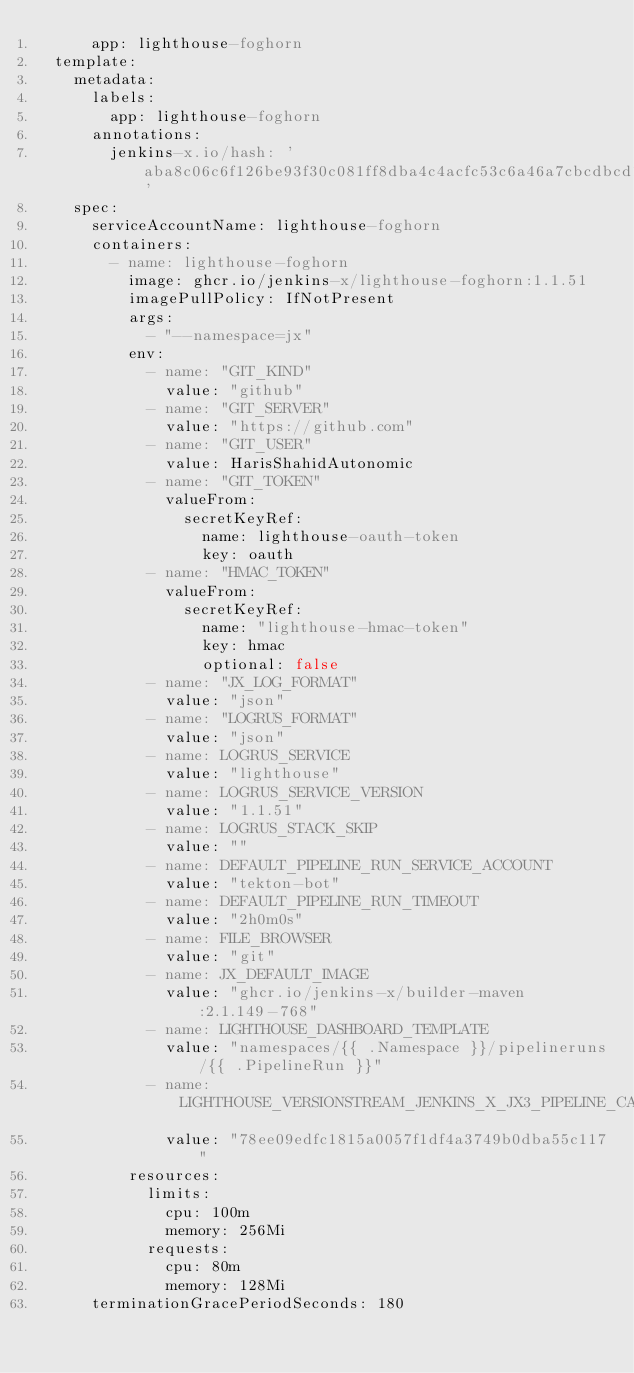Convert code to text. <code><loc_0><loc_0><loc_500><loc_500><_YAML_>      app: lighthouse-foghorn
  template:
    metadata:
      labels:
        app: lighthouse-foghorn
      annotations:
        jenkins-x.io/hash: 'aba8c06c6f126be93f30c081ff8dba4c4acfc53c6a46a7cbcdbcd1aceede6bf8'
    spec:
      serviceAccountName: lighthouse-foghorn
      containers:
        - name: lighthouse-foghorn
          image: ghcr.io/jenkins-x/lighthouse-foghorn:1.1.51
          imagePullPolicy: IfNotPresent
          args:
            - "--namespace=jx"
          env:
            - name: "GIT_KIND"
              value: "github"
            - name: "GIT_SERVER"
              value: "https://github.com"
            - name: "GIT_USER"
              value: HarisShahidAutonomic
            - name: "GIT_TOKEN"
              valueFrom:
                secretKeyRef:
                  name: lighthouse-oauth-token
                  key: oauth
            - name: "HMAC_TOKEN"
              valueFrom:
                secretKeyRef:
                  name: "lighthouse-hmac-token"
                  key: hmac
                  optional: false
            - name: "JX_LOG_FORMAT"
              value: "json"
            - name: "LOGRUS_FORMAT"
              value: "json"
            - name: LOGRUS_SERVICE
              value: "lighthouse"
            - name: LOGRUS_SERVICE_VERSION
              value: "1.1.51"
            - name: LOGRUS_STACK_SKIP
              value: ""
            - name: DEFAULT_PIPELINE_RUN_SERVICE_ACCOUNT
              value: "tekton-bot"
            - name: DEFAULT_PIPELINE_RUN_TIMEOUT
              value: "2h0m0s"
            - name: FILE_BROWSER
              value: "git"
            - name: JX_DEFAULT_IMAGE
              value: "ghcr.io/jenkins-x/builder-maven:2.1.149-768"
            - name: LIGHTHOUSE_DASHBOARD_TEMPLATE
              value: "namespaces/{{ .Namespace }}/pipelineruns/{{ .PipelineRun }}"
            - name: LIGHTHOUSE_VERSIONSTREAM_JENKINS_X_JX3_PIPELINE_CATALOG
              value: "78ee09edfc1815a0057f1df4a3749b0dba55c117"
          resources:
            limits:
              cpu: 100m
              memory: 256Mi
            requests:
              cpu: 80m
              memory: 128Mi
      terminationGracePeriodSeconds: 180
</code> 